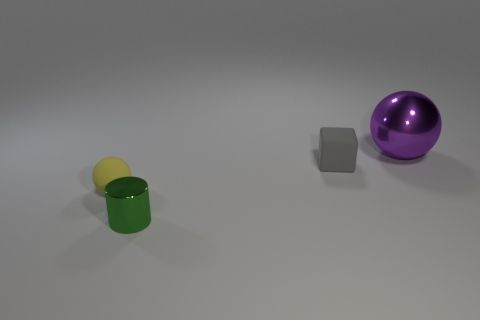Subtract all cylinders. How many objects are left? 3 Subtract 1 balls. How many balls are left? 1 Subtract all cyan balls. Subtract all red cylinders. How many balls are left? 2 Subtract all yellow cylinders. How many brown cubes are left? 0 Subtract all yellow spheres. Subtract all cubes. How many objects are left? 2 Add 2 gray rubber things. How many gray rubber things are left? 3 Add 2 small rubber balls. How many small rubber balls exist? 3 Add 3 tiny rubber spheres. How many objects exist? 7 Subtract all yellow spheres. How many spheres are left? 1 Subtract 0 blue blocks. How many objects are left? 4 